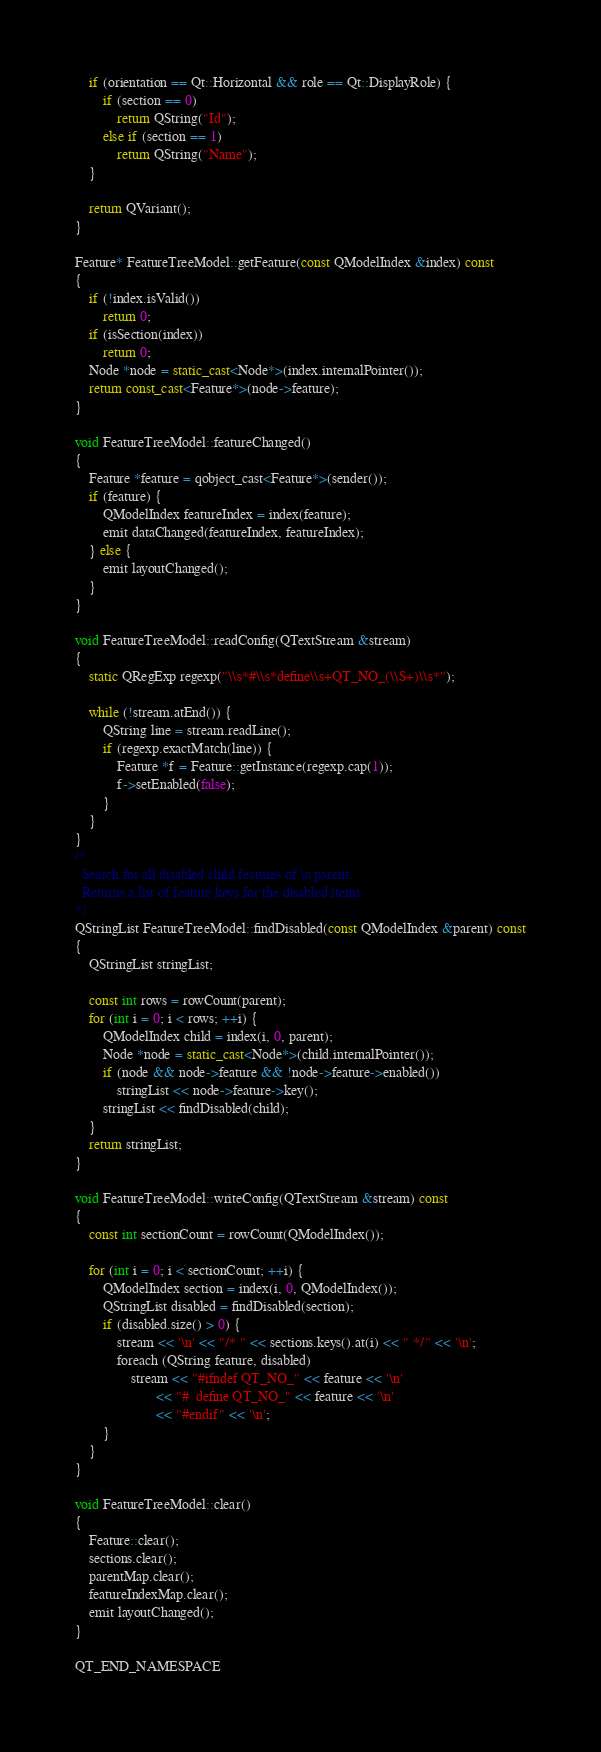Convert code to text. <code><loc_0><loc_0><loc_500><loc_500><_C++_>    if (orientation == Qt::Horizontal && role == Qt::DisplayRole) {
        if (section == 0)
            return QString("Id");
        else if (section == 1)
            return QString("Name");
    }

    return QVariant();
}

Feature* FeatureTreeModel::getFeature(const QModelIndex &index) const
{
    if (!index.isValid())
        return 0;
    if (isSection(index))
        return 0;
    Node *node = static_cast<Node*>(index.internalPointer());
    return const_cast<Feature*>(node->feature);
}

void FeatureTreeModel::featureChanged()
{
    Feature *feature = qobject_cast<Feature*>(sender());
    if (feature) {
        QModelIndex featureIndex = index(feature);
        emit dataChanged(featureIndex, featureIndex);
    } else {
        emit layoutChanged();
    }
}

void FeatureTreeModel::readConfig(QTextStream &stream)
{
    static QRegExp regexp("\\s*#\\s*define\\s+QT_NO_(\\S+)\\s*");

    while (!stream.atEnd()) {
        QString line = stream.readLine();
        if (regexp.exactMatch(line)) {
            Feature *f = Feature::getInstance(regexp.cap(1));
            f->setEnabled(false);
        }
    }
}
/*
  Search for all disabled child features of \a parent.
  Returns a list of feature keys for the disabled items.
*/
QStringList FeatureTreeModel::findDisabled(const QModelIndex &parent) const
{
    QStringList stringList;

    const int rows = rowCount(parent);
    for (int i = 0; i < rows; ++i) {
        QModelIndex child = index(i, 0, parent);
        Node *node = static_cast<Node*>(child.internalPointer());
        if (node && node->feature && !node->feature->enabled())
            stringList << node->feature->key();
        stringList << findDisabled(child);
    }
    return stringList;
}

void FeatureTreeModel::writeConfig(QTextStream &stream) const
{
    const int sectionCount = rowCount(QModelIndex());

    for (int i = 0; i < sectionCount; ++i) {
        QModelIndex section = index(i, 0, QModelIndex());
        QStringList disabled = findDisabled(section);
        if (disabled.size() > 0) {
            stream << '\n' << "/* " << sections.keys().at(i) << " */" << '\n';
            foreach (QString feature, disabled)
                stream << "#ifndef QT_NO_" << feature << '\n'
                       << "#  define QT_NO_" << feature << '\n'
                       << "#endif" << '\n';
        }
    }
}

void FeatureTreeModel::clear()
{
    Feature::clear();
    sections.clear();
    parentMap.clear();
    featureIndexMap.clear();
    emit layoutChanged();
}

QT_END_NAMESPACE
</code> 